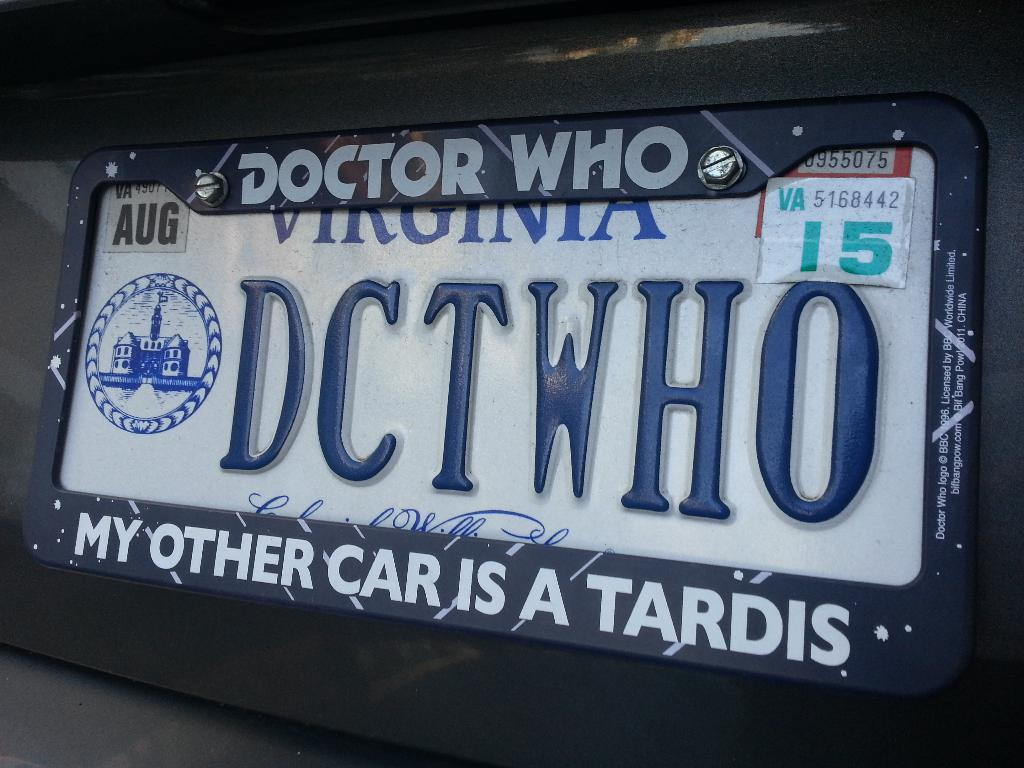Provide a one-sentence caption for the provided image. License plate that has a Doctor Who cover from Virginia. 